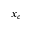Convert formula to latex. <formula><loc_0><loc_0><loc_500><loc_500>x _ { c }</formula> 